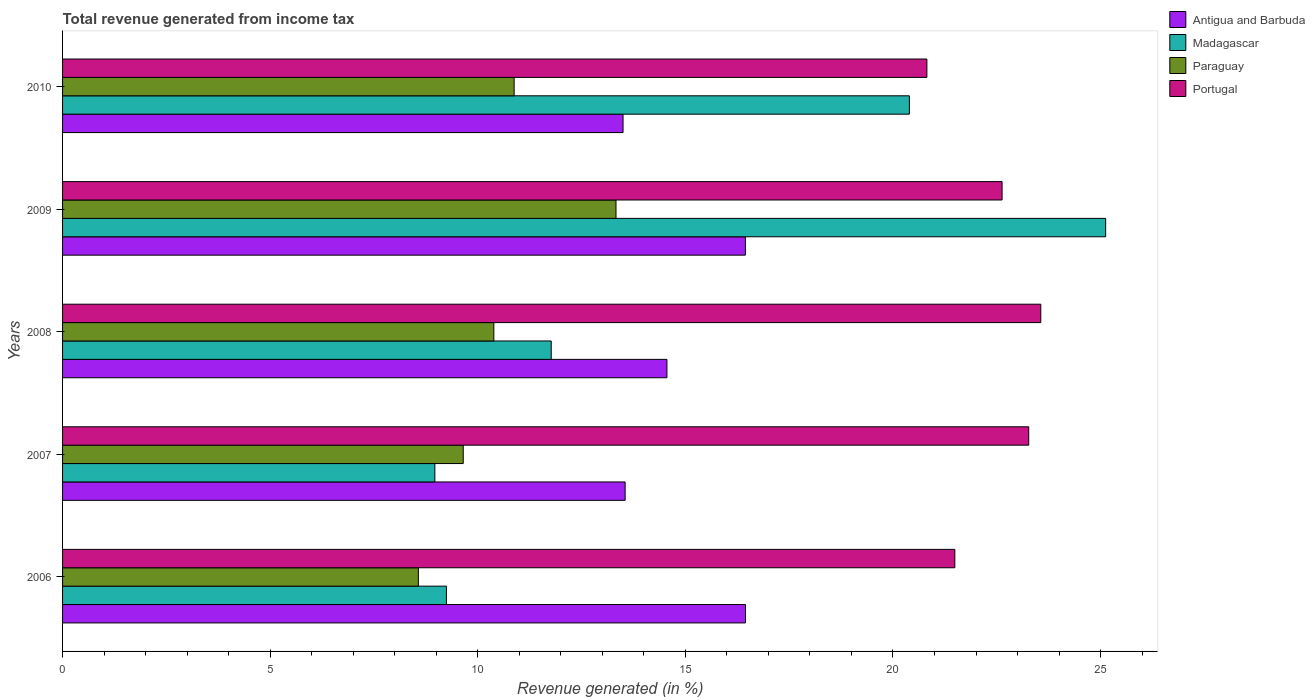How many different coloured bars are there?
Offer a very short reply. 4. How many groups of bars are there?
Offer a terse response. 5. Are the number of bars per tick equal to the number of legend labels?
Keep it short and to the point. Yes. Are the number of bars on each tick of the Y-axis equal?
Make the answer very short. Yes. What is the label of the 5th group of bars from the top?
Offer a very short reply. 2006. In how many cases, is the number of bars for a given year not equal to the number of legend labels?
Provide a short and direct response. 0. What is the total revenue generated in Madagascar in 2006?
Offer a terse response. 9.24. Across all years, what is the maximum total revenue generated in Portugal?
Give a very brief answer. 23.56. Across all years, what is the minimum total revenue generated in Portugal?
Provide a short and direct response. 20.82. In which year was the total revenue generated in Portugal maximum?
Provide a succinct answer. 2008. What is the total total revenue generated in Paraguay in the graph?
Make the answer very short. 52.81. What is the difference between the total revenue generated in Antigua and Barbuda in 2009 and that in 2010?
Provide a short and direct response. 2.95. What is the difference between the total revenue generated in Madagascar in 2006 and the total revenue generated in Antigua and Barbuda in 2010?
Your answer should be compact. -4.25. What is the average total revenue generated in Portugal per year?
Offer a terse response. 22.35. In the year 2007, what is the difference between the total revenue generated in Paraguay and total revenue generated in Antigua and Barbuda?
Offer a very short reply. -3.9. What is the ratio of the total revenue generated in Portugal in 2007 to that in 2009?
Provide a succinct answer. 1.03. Is the total revenue generated in Portugal in 2006 less than that in 2007?
Your answer should be very brief. Yes. What is the difference between the highest and the second highest total revenue generated in Paraguay?
Offer a terse response. 2.45. What is the difference between the highest and the lowest total revenue generated in Paraguay?
Offer a terse response. 4.76. In how many years, is the total revenue generated in Portugal greater than the average total revenue generated in Portugal taken over all years?
Make the answer very short. 3. Is it the case that in every year, the sum of the total revenue generated in Madagascar and total revenue generated in Paraguay is greater than the sum of total revenue generated in Antigua and Barbuda and total revenue generated in Portugal?
Ensure brevity in your answer.  No. What does the 2nd bar from the top in 2007 represents?
Your answer should be very brief. Paraguay. What does the 3rd bar from the bottom in 2009 represents?
Provide a short and direct response. Paraguay. Is it the case that in every year, the sum of the total revenue generated in Portugal and total revenue generated in Antigua and Barbuda is greater than the total revenue generated in Madagascar?
Ensure brevity in your answer.  Yes. Are all the bars in the graph horizontal?
Offer a terse response. Yes. How many years are there in the graph?
Ensure brevity in your answer.  5. Are the values on the major ticks of X-axis written in scientific E-notation?
Provide a succinct answer. No. Does the graph contain any zero values?
Offer a very short reply. No. Where does the legend appear in the graph?
Your answer should be compact. Top right. What is the title of the graph?
Your answer should be compact. Total revenue generated from income tax. Does "Gambia, The" appear as one of the legend labels in the graph?
Keep it short and to the point. No. What is the label or title of the X-axis?
Your answer should be very brief. Revenue generated (in %). What is the label or title of the Y-axis?
Provide a short and direct response. Years. What is the Revenue generated (in %) in Antigua and Barbuda in 2006?
Offer a very short reply. 16.45. What is the Revenue generated (in %) of Madagascar in 2006?
Offer a terse response. 9.24. What is the Revenue generated (in %) in Paraguay in 2006?
Provide a short and direct response. 8.57. What is the Revenue generated (in %) of Portugal in 2006?
Your answer should be compact. 21.49. What is the Revenue generated (in %) in Antigua and Barbuda in 2007?
Provide a succinct answer. 13.55. What is the Revenue generated (in %) in Madagascar in 2007?
Keep it short and to the point. 8.97. What is the Revenue generated (in %) in Paraguay in 2007?
Provide a short and direct response. 9.65. What is the Revenue generated (in %) in Portugal in 2007?
Offer a terse response. 23.27. What is the Revenue generated (in %) in Antigua and Barbuda in 2008?
Offer a very short reply. 14.56. What is the Revenue generated (in %) of Madagascar in 2008?
Offer a very short reply. 11.77. What is the Revenue generated (in %) in Paraguay in 2008?
Give a very brief answer. 10.39. What is the Revenue generated (in %) of Portugal in 2008?
Ensure brevity in your answer.  23.56. What is the Revenue generated (in %) in Antigua and Barbuda in 2009?
Provide a succinct answer. 16.45. What is the Revenue generated (in %) of Madagascar in 2009?
Ensure brevity in your answer.  25.12. What is the Revenue generated (in %) in Paraguay in 2009?
Offer a terse response. 13.33. What is the Revenue generated (in %) of Portugal in 2009?
Offer a very short reply. 22.63. What is the Revenue generated (in %) of Antigua and Barbuda in 2010?
Offer a terse response. 13.5. What is the Revenue generated (in %) of Madagascar in 2010?
Your answer should be very brief. 20.39. What is the Revenue generated (in %) in Paraguay in 2010?
Give a very brief answer. 10.88. What is the Revenue generated (in %) of Portugal in 2010?
Give a very brief answer. 20.82. Across all years, what is the maximum Revenue generated (in %) of Antigua and Barbuda?
Your answer should be compact. 16.45. Across all years, what is the maximum Revenue generated (in %) of Madagascar?
Make the answer very short. 25.12. Across all years, what is the maximum Revenue generated (in %) of Paraguay?
Offer a terse response. 13.33. Across all years, what is the maximum Revenue generated (in %) in Portugal?
Your answer should be compact. 23.56. Across all years, what is the minimum Revenue generated (in %) in Antigua and Barbuda?
Make the answer very short. 13.5. Across all years, what is the minimum Revenue generated (in %) of Madagascar?
Your answer should be compact. 8.97. Across all years, what is the minimum Revenue generated (in %) of Paraguay?
Make the answer very short. 8.57. Across all years, what is the minimum Revenue generated (in %) in Portugal?
Your answer should be very brief. 20.82. What is the total Revenue generated (in %) in Antigua and Barbuda in the graph?
Provide a short and direct response. 74.5. What is the total Revenue generated (in %) in Madagascar in the graph?
Provide a short and direct response. 75.5. What is the total Revenue generated (in %) of Paraguay in the graph?
Your response must be concise. 52.81. What is the total Revenue generated (in %) in Portugal in the graph?
Ensure brevity in your answer.  111.76. What is the difference between the Revenue generated (in %) of Antigua and Barbuda in 2006 and that in 2007?
Offer a terse response. 2.9. What is the difference between the Revenue generated (in %) in Madagascar in 2006 and that in 2007?
Keep it short and to the point. 0.28. What is the difference between the Revenue generated (in %) of Paraguay in 2006 and that in 2007?
Your answer should be very brief. -1.08. What is the difference between the Revenue generated (in %) of Portugal in 2006 and that in 2007?
Offer a very short reply. -1.78. What is the difference between the Revenue generated (in %) of Antigua and Barbuda in 2006 and that in 2008?
Your response must be concise. 1.89. What is the difference between the Revenue generated (in %) of Madagascar in 2006 and that in 2008?
Your response must be concise. -2.52. What is the difference between the Revenue generated (in %) of Paraguay in 2006 and that in 2008?
Ensure brevity in your answer.  -1.82. What is the difference between the Revenue generated (in %) of Portugal in 2006 and that in 2008?
Ensure brevity in your answer.  -2.07. What is the difference between the Revenue generated (in %) of Antigua and Barbuda in 2006 and that in 2009?
Make the answer very short. 0. What is the difference between the Revenue generated (in %) of Madagascar in 2006 and that in 2009?
Give a very brief answer. -15.88. What is the difference between the Revenue generated (in %) of Paraguay in 2006 and that in 2009?
Give a very brief answer. -4.76. What is the difference between the Revenue generated (in %) of Portugal in 2006 and that in 2009?
Your answer should be compact. -1.14. What is the difference between the Revenue generated (in %) in Antigua and Barbuda in 2006 and that in 2010?
Keep it short and to the point. 2.95. What is the difference between the Revenue generated (in %) in Madagascar in 2006 and that in 2010?
Keep it short and to the point. -11.15. What is the difference between the Revenue generated (in %) of Paraguay in 2006 and that in 2010?
Offer a terse response. -2.31. What is the difference between the Revenue generated (in %) in Portugal in 2006 and that in 2010?
Make the answer very short. 0.67. What is the difference between the Revenue generated (in %) of Antigua and Barbuda in 2007 and that in 2008?
Offer a terse response. -1.01. What is the difference between the Revenue generated (in %) of Madagascar in 2007 and that in 2008?
Your answer should be very brief. -2.8. What is the difference between the Revenue generated (in %) in Paraguay in 2007 and that in 2008?
Your response must be concise. -0.74. What is the difference between the Revenue generated (in %) in Portugal in 2007 and that in 2008?
Your answer should be very brief. -0.29. What is the difference between the Revenue generated (in %) in Antigua and Barbuda in 2007 and that in 2009?
Offer a very short reply. -2.9. What is the difference between the Revenue generated (in %) in Madagascar in 2007 and that in 2009?
Provide a succinct answer. -16.16. What is the difference between the Revenue generated (in %) in Paraguay in 2007 and that in 2009?
Offer a terse response. -3.68. What is the difference between the Revenue generated (in %) of Portugal in 2007 and that in 2009?
Give a very brief answer. 0.64. What is the difference between the Revenue generated (in %) of Antigua and Barbuda in 2007 and that in 2010?
Give a very brief answer. 0.05. What is the difference between the Revenue generated (in %) of Madagascar in 2007 and that in 2010?
Ensure brevity in your answer.  -11.43. What is the difference between the Revenue generated (in %) in Paraguay in 2007 and that in 2010?
Keep it short and to the point. -1.23. What is the difference between the Revenue generated (in %) in Portugal in 2007 and that in 2010?
Provide a short and direct response. 2.45. What is the difference between the Revenue generated (in %) of Antigua and Barbuda in 2008 and that in 2009?
Give a very brief answer. -1.89. What is the difference between the Revenue generated (in %) in Madagascar in 2008 and that in 2009?
Provide a succinct answer. -13.35. What is the difference between the Revenue generated (in %) of Paraguay in 2008 and that in 2009?
Your answer should be compact. -2.94. What is the difference between the Revenue generated (in %) of Portugal in 2008 and that in 2009?
Your response must be concise. 0.93. What is the difference between the Revenue generated (in %) in Antigua and Barbuda in 2008 and that in 2010?
Provide a succinct answer. 1.06. What is the difference between the Revenue generated (in %) in Madagascar in 2008 and that in 2010?
Your response must be concise. -8.63. What is the difference between the Revenue generated (in %) in Paraguay in 2008 and that in 2010?
Provide a succinct answer. -0.49. What is the difference between the Revenue generated (in %) in Portugal in 2008 and that in 2010?
Make the answer very short. 2.74. What is the difference between the Revenue generated (in %) of Antigua and Barbuda in 2009 and that in 2010?
Provide a short and direct response. 2.95. What is the difference between the Revenue generated (in %) of Madagascar in 2009 and that in 2010?
Offer a very short reply. 4.73. What is the difference between the Revenue generated (in %) of Paraguay in 2009 and that in 2010?
Offer a very short reply. 2.45. What is the difference between the Revenue generated (in %) of Portugal in 2009 and that in 2010?
Keep it short and to the point. 1.81. What is the difference between the Revenue generated (in %) of Antigua and Barbuda in 2006 and the Revenue generated (in %) of Madagascar in 2007?
Your response must be concise. 7.48. What is the difference between the Revenue generated (in %) of Antigua and Barbuda in 2006 and the Revenue generated (in %) of Paraguay in 2007?
Your answer should be compact. 6.8. What is the difference between the Revenue generated (in %) in Antigua and Barbuda in 2006 and the Revenue generated (in %) in Portugal in 2007?
Offer a terse response. -6.82. What is the difference between the Revenue generated (in %) of Madagascar in 2006 and the Revenue generated (in %) of Paraguay in 2007?
Offer a terse response. -0.41. What is the difference between the Revenue generated (in %) in Madagascar in 2006 and the Revenue generated (in %) in Portugal in 2007?
Make the answer very short. -14.02. What is the difference between the Revenue generated (in %) in Paraguay in 2006 and the Revenue generated (in %) in Portugal in 2007?
Ensure brevity in your answer.  -14.7. What is the difference between the Revenue generated (in %) of Antigua and Barbuda in 2006 and the Revenue generated (in %) of Madagascar in 2008?
Offer a terse response. 4.68. What is the difference between the Revenue generated (in %) of Antigua and Barbuda in 2006 and the Revenue generated (in %) of Paraguay in 2008?
Your answer should be compact. 6.06. What is the difference between the Revenue generated (in %) of Antigua and Barbuda in 2006 and the Revenue generated (in %) of Portugal in 2008?
Offer a terse response. -7.11. What is the difference between the Revenue generated (in %) in Madagascar in 2006 and the Revenue generated (in %) in Paraguay in 2008?
Provide a succinct answer. -1.14. What is the difference between the Revenue generated (in %) of Madagascar in 2006 and the Revenue generated (in %) of Portugal in 2008?
Offer a terse response. -14.32. What is the difference between the Revenue generated (in %) of Paraguay in 2006 and the Revenue generated (in %) of Portugal in 2008?
Provide a short and direct response. -14.99. What is the difference between the Revenue generated (in %) in Antigua and Barbuda in 2006 and the Revenue generated (in %) in Madagascar in 2009?
Offer a very short reply. -8.67. What is the difference between the Revenue generated (in %) of Antigua and Barbuda in 2006 and the Revenue generated (in %) of Paraguay in 2009?
Your answer should be compact. 3.12. What is the difference between the Revenue generated (in %) of Antigua and Barbuda in 2006 and the Revenue generated (in %) of Portugal in 2009?
Give a very brief answer. -6.18. What is the difference between the Revenue generated (in %) in Madagascar in 2006 and the Revenue generated (in %) in Paraguay in 2009?
Offer a very short reply. -4.08. What is the difference between the Revenue generated (in %) of Madagascar in 2006 and the Revenue generated (in %) of Portugal in 2009?
Ensure brevity in your answer.  -13.38. What is the difference between the Revenue generated (in %) of Paraguay in 2006 and the Revenue generated (in %) of Portugal in 2009?
Provide a short and direct response. -14.06. What is the difference between the Revenue generated (in %) of Antigua and Barbuda in 2006 and the Revenue generated (in %) of Madagascar in 2010?
Your answer should be compact. -3.95. What is the difference between the Revenue generated (in %) of Antigua and Barbuda in 2006 and the Revenue generated (in %) of Paraguay in 2010?
Offer a very short reply. 5.57. What is the difference between the Revenue generated (in %) of Antigua and Barbuda in 2006 and the Revenue generated (in %) of Portugal in 2010?
Offer a very short reply. -4.37. What is the difference between the Revenue generated (in %) in Madagascar in 2006 and the Revenue generated (in %) in Paraguay in 2010?
Provide a short and direct response. -1.63. What is the difference between the Revenue generated (in %) in Madagascar in 2006 and the Revenue generated (in %) in Portugal in 2010?
Offer a very short reply. -11.57. What is the difference between the Revenue generated (in %) of Paraguay in 2006 and the Revenue generated (in %) of Portugal in 2010?
Provide a short and direct response. -12.25. What is the difference between the Revenue generated (in %) in Antigua and Barbuda in 2007 and the Revenue generated (in %) in Madagascar in 2008?
Your response must be concise. 1.78. What is the difference between the Revenue generated (in %) of Antigua and Barbuda in 2007 and the Revenue generated (in %) of Paraguay in 2008?
Ensure brevity in your answer.  3.16. What is the difference between the Revenue generated (in %) in Antigua and Barbuda in 2007 and the Revenue generated (in %) in Portugal in 2008?
Offer a terse response. -10.01. What is the difference between the Revenue generated (in %) of Madagascar in 2007 and the Revenue generated (in %) of Paraguay in 2008?
Give a very brief answer. -1.42. What is the difference between the Revenue generated (in %) of Madagascar in 2007 and the Revenue generated (in %) of Portugal in 2008?
Offer a terse response. -14.59. What is the difference between the Revenue generated (in %) of Paraguay in 2007 and the Revenue generated (in %) of Portugal in 2008?
Give a very brief answer. -13.91. What is the difference between the Revenue generated (in %) in Antigua and Barbuda in 2007 and the Revenue generated (in %) in Madagascar in 2009?
Provide a short and direct response. -11.57. What is the difference between the Revenue generated (in %) of Antigua and Barbuda in 2007 and the Revenue generated (in %) of Paraguay in 2009?
Provide a short and direct response. 0.22. What is the difference between the Revenue generated (in %) of Antigua and Barbuda in 2007 and the Revenue generated (in %) of Portugal in 2009?
Your answer should be very brief. -9.08. What is the difference between the Revenue generated (in %) in Madagascar in 2007 and the Revenue generated (in %) in Paraguay in 2009?
Keep it short and to the point. -4.36. What is the difference between the Revenue generated (in %) in Madagascar in 2007 and the Revenue generated (in %) in Portugal in 2009?
Your answer should be very brief. -13.66. What is the difference between the Revenue generated (in %) of Paraguay in 2007 and the Revenue generated (in %) of Portugal in 2009?
Give a very brief answer. -12.98. What is the difference between the Revenue generated (in %) in Antigua and Barbuda in 2007 and the Revenue generated (in %) in Madagascar in 2010?
Your answer should be compact. -6.85. What is the difference between the Revenue generated (in %) in Antigua and Barbuda in 2007 and the Revenue generated (in %) in Paraguay in 2010?
Your response must be concise. 2.67. What is the difference between the Revenue generated (in %) in Antigua and Barbuda in 2007 and the Revenue generated (in %) in Portugal in 2010?
Ensure brevity in your answer.  -7.27. What is the difference between the Revenue generated (in %) of Madagascar in 2007 and the Revenue generated (in %) of Paraguay in 2010?
Provide a succinct answer. -1.91. What is the difference between the Revenue generated (in %) in Madagascar in 2007 and the Revenue generated (in %) in Portugal in 2010?
Your response must be concise. -11.85. What is the difference between the Revenue generated (in %) in Paraguay in 2007 and the Revenue generated (in %) in Portugal in 2010?
Offer a terse response. -11.17. What is the difference between the Revenue generated (in %) in Antigua and Barbuda in 2008 and the Revenue generated (in %) in Madagascar in 2009?
Make the answer very short. -10.57. What is the difference between the Revenue generated (in %) in Antigua and Barbuda in 2008 and the Revenue generated (in %) in Paraguay in 2009?
Keep it short and to the point. 1.23. What is the difference between the Revenue generated (in %) in Antigua and Barbuda in 2008 and the Revenue generated (in %) in Portugal in 2009?
Provide a succinct answer. -8.07. What is the difference between the Revenue generated (in %) in Madagascar in 2008 and the Revenue generated (in %) in Paraguay in 2009?
Offer a terse response. -1.56. What is the difference between the Revenue generated (in %) in Madagascar in 2008 and the Revenue generated (in %) in Portugal in 2009?
Make the answer very short. -10.86. What is the difference between the Revenue generated (in %) in Paraguay in 2008 and the Revenue generated (in %) in Portugal in 2009?
Your response must be concise. -12.24. What is the difference between the Revenue generated (in %) of Antigua and Barbuda in 2008 and the Revenue generated (in %) of Madagascar in 2010?
Make the answer very short. -5.84. What is the difference between the Revenue generated (in %) in Antigua and Barbuda in 2008 and the Revenue generated (in %) in Paraguay in 2010?
Make the answer very short. 3.68. What is the difference between the Revenue generated (in %) of Antigua and Barbuda in 2008 and the Revenue generated (in %) of Portugal in 2010?
Your answer should be very brief. -6.26. What is the difference between the Revenue generated (in %) in Madagascar in 2008 and the Revenue generated (in %) in Paraguay in 2010?
Ensure brevity in your answer.  0.89. What is the difference between the Revenue generated (in %) in Madagascar in 2008 and the Revenue generated (in %) in Portugal in 2010?
Offer a very short reply. -9.05. What is the difference between the Revenue generated (in %) in Paraguay in 2008 and the Revenue generated (in %) in Portugal in 2010?
Provide a succinct answer. -10.43. What is the difference between the Revenue generated (in %) of Antigua and Barbuda in 2009 and the Revenue generated (in %) of Madagascar in 2010?
Keep it short and to the point. -3.95. What is the difference between the Revenue generated (in %) of Antigua and Barbuda in 2009 and the Revenue generated (in %) of Paraguay in 2010?
Make the answer very short. 5.57. What is the difference between the Revenue generated (in %) in Antigua and Barbuda in 2009 and the Revenue generated (in %) in Portugal in 2010?
Keep it short and to the point. -4.37. What is the difference between the Revenue generated (in %) of Madagascar in 2009 and the Revenue generated (in %) of Paraguay in 2010?
Give a very brief answer. 14.25. What is the difference between the Revenue generated (in %) in Madagascar in 2009 and the Revenue generated (in %) in Portugal in 2010?
Give a very brief answer. 4.31. What is the difference between the Revenue generated (in %) of Paraguay in 2009 and the Revenue generated (in %) of Portugal in 2010?
Your answer should be compact. -7.49. What is the average Revenue generated (in %) in Antigua and Barbuda per year?
Your answer should be compact. 14.9. What is the average Revenue generated (in %) of Madagascar per year?
Ensure brevity in your answer.  15.1. What is the average Revenue generated (in %) in Paraguay per year?
Offer a very short reply. 10.56. What is the average Revenue generated (in %) in Portugal per year?
Offer a terse response. 22.35. In the year 2006, what is the difference between the Revenue generated (in %) of Antigua and Barbuda and Revenue generated (in %) of Madagascar?
Offer a terse response. 7.2. In the year 2006, what is the difference between the Revenue generated (in %) of Antigua and Barbuda and Revenue generated (in %) of Paraguay?
Your response must be concise. 7.88. In the year 2006, what is the difference between the Revenue generated (in %) of Antigua and Barbuda and Revenue generated (in %) of Portugal?
Keep it short and to the point. -5.04. In the year 2006, what is the difference between the Revenue generated (in %) of Madagascar and Revenue generated (in %) of Paraguay?
Your answer should be very brief. 0.68. In the year 2006, what is the difference between the Revenue generated (in %) in Madagascar and Revenue generated (in %) in Portugal?
Provide a short and direct response. -12.25. In the year 2006, what is the difference between the Revenue generated (in %) in Paraguay and Revenue generated (in %) in Portugal?
Offer a very short reply. -12.92. In the year 2007, what is the difference between the Revenue generated (in %) in Antigua and Barbuda and Revenue generated (in %) in Madagascar?
Your response must be concise. 4.58. In the year 2007, what is the difference between the Revenue generated (in %) in Antigua and Barbuda and Revenue generated (in %) in Paraguay?
Your answer should be very brief. 3.9. In the year 2007, what is the difference between the Revenue generated (in %) in Antigua and Barbuda and Revenue generated (in %) in Portugal?
Make the answer very short. -9.72. In the year 2007, what is the difference between the Revenue generated (in %) of Madagascar and Revenue generated (in %) of Paraguay?
Ensure brevity in your answer.  -0.68. In the year 2007, what is the difference between the Revenue generated (in %) in Madagascar and Revenue generated (in %) in Portugal?
Your response must be concise. -14.3. In the year 2007, what is the difference between the Revenue generated (in %) in Paraguay and Revenue generated (in %) in Portugal?
Your answer should be compact. -13.62. In the year 2008, what is the difference between the Revenue generated (in %) of Antigua and Barbuda and Revenue generated (in %) of Madagascar?
Your answer should be compact. 2.79. In the year 2008, what is the difference between the Revenue generated (in %) in Antigua and Barbuda and Revenue generated (in %) in Paraguay?
Ensure brevity in your answer.  4.17. In the year 2008, what is the difference between the Revenue generated (in %) of Antigua and Barbuda and Revenue generated (in %) of Portugal?
Offer a terse response. -9. In the year 2008, what is the difference between the Revenue generated (in %) of Madagascar and Revenue generated (in %) of Paraguay?
Make the answer very short. 1.38. In the year 2008, what is the difference between the Revenue generated (in %) in Madagascar and Revenue generated (in %) in Portugal?
Offer a terse response. -11.79. In the year 2008, what is the difference between the Revenue generated (in %) in Paraguay and Revenue generated (in %) in Portugal?
Provide a short and direct response. -13.17. In the year 2009, what is the difference between the Revenue generated (in %) of Antigua and Barbuda and Revenue generated (in %) of Madagascar?
Your answer should be very brief. -8.68. In the year 2009, what is the difference between the Revenue generated (in %) of Antigua and Barbuda and Revenue generated (in %) of Paraguay?
Your response must be concise. 3.12. In the year 2009, what is the difference between the Revenue generated (in %) of Antigua and Barbuda and Revenue generated (in %) of Portugal?
Your answer should be very brief. -6.18. In the year 2009, what is the difference between the Revenue generated (in %) in Madagascar and Revenue generated (in %) in Paraguay?
Keep it short and to the point. 11.79. In the year 2009, what is the difference between the Revenue generated (in %) of Madagascar and Revenue generated (in %) of Portugal?
Offer a very short reply. 2.49. In the year 2009, what is the difference between the Revenue generated (in %) in Paraguay and Revenue generated (in %) in Portugal?
Provide a succinct answer. -9.3. In the year 2010, what is the difference between the Revenue generated (in %) in Antigua and Barbuda and Revenue generated (in %) in Madagascar?
Your answer should be very brief. -6.9. In the year 2010, what is the difference between the Revenue generated (in %) in Antigua and Barbuda and Revenue generated (in %) in Paraguay?
Provide a short and direct response. 2.62. In the year 2010, what is the difference between the Revenue generated (in %) in Antigua and Barbuda and Revenue generated (in %) in Portugal?
Your answer should be very brief. -7.32. In the year 2010, what is the difference between the Revenue generated (in %) in Madagascar and Revenue generated (in %) in Paraguay?
Provide a succinct answer. 9.52. In the year 2010, what is the difference between the Revenue generated (in %) of Madagascar and Revenue generated (in %) of Portugal?
Give a very brief answer. -0.42. In the year 2010, what is the difference between the Revenue generated (in %) in Paraguay and Revenue generated (in %) in Portugal?
Your answer should be compact. -9.94. What is the ratio of the Revenue generated (in %) in Antigua and Barbuda in 2006 to that in 2007?
Provide a short and direct response. 1.21. What is the ratio of the Revenue generated (in %) of Madagascar in 2006 to that in 2007?
Your response must be concise. 1.03. What is the ratio of the Revenue generated (in %) in Paraguay in 2006 to that in 2007?
Give a very brief answer. 0.89. What is the ratio of the Revenue generated (in %) of Portugal in 2006 to that in 2007?
Keep it short and to the point. 0.92. What is the ratio of the Revenue generated (in %) of Antigua and Barbuda in 2006 to that in 2008?
Give a very brief answer. 1.13. What is the ratio of the Revenue generated (in %) in Madagascar in 2006 to that in 2008?
Your answer should be compact. 0.79. What is the ratio of the Revenue generated (in %) of Paraguay in 2006 to that in 2008?
Your answer should be compact. 0.82. What is the ratio of the Revenue generated (in %) of Portugal in 2006 to that in 2008?
Give a very brief answer. 0.91. What is the ratio of the Revenue generated (in %) in Antigua and Barbuda in 2006 to that in 2009?
Your answer should be very brief. 1. What is the ratio of the Revenue generated (in %) of Madagascar in 2006 to that in 2009?
Give a very brief answer. 0.37. What is the ratio of the Revenue generated (in %) of Paraguay in 2006 to that in 2009?
Your answer should be very brief. 0.64. What is the ratio of the Revenue generated (in %) of Portugal in 2006 to that in 2009?
Keep it short and to the point. 0.95. What is the ratio of the Revenue generated (in %) in Antigua and Barbuda in 2006 to that in 2010?
Ensure brevity in your answer.  1.22. What is the ratio of the Revenue generated (in %) of Madagascar in 2006 to that in 2010?
Your response must be concise. 0.45. What is the ratio of the Revenue generated (in %) of Paraguay in 2006 to that in 2010?
Your answer should be very brief. 0.79. What is the ratio of the Revenue generated (in %) of Portugal in 2006 to that in 2010?
Your answer should be very brief. 1.03. What is the ratio of the Revenue generated (in %) in Antigua and Barbuda in 2007 to that in 2008?
Your response must be concise. 0.93. What is the ratio of the Revenue generated (in %) in Madagascar in 2007 to that in 2008?
Provide a succinct answer. 0.76. What is the ratio of the Revenue generated (in %) in Paraguay in 2007 to that in 2008?
Provide a short and direct response. 0.93. What is the ratio of the Revenue generated (in %) in Antigua and Barbuda in 2007 to that in 2009?
Offer a very short reply. 0.82. What is the ratio of the Revenue generated (in %) in Madagascar in 2007 to that in 2009?
Offer a terse response. 0.36. What is the ratio of the Revenue generated (in %) in Paraguay in 2007 to that in 2009?
Your response must be concise. 0.72. What is the ratio of the Revenue generated (in %) of Portugal in 2007 to that in 2009?
Your response must be concise. 1.03. What is the ratio of the Revenue generated (in %) in Madagascar in 2007 to that in 2010?
Provide a succinct answer. 0.44. What is the ratio of the Revenue generated (in %) in Paraguay in 2007 to that in 2010?
Your answer should be compact. 0.89. What is the ratio of the Revenue generated (in %) of Portugal in 2007 to that in 2010?
Provide a succinct answer. 1.12. What is the ratio of the Revenue generated (in %) of Antigua and Barbuda in 2008 to that in 2009?
Your response must be concise. 0.89. What is the ratio of the Revenue generated (in %) in Madagascar in 2008 to that in 2009?
Ensure brevity in your answer.  0.47. What is the ratio of the Revenue generated (in %) of Paraguay in 2008 to that in 2009?
Give a very brief answer. 0.78. What is the ratio of the Revenue generated (in %) of Portugal in 2008 to that in 2009?
Keep it short and to the point. 1.04. What is the ratio of the Revenue generated (in %) in Antigua and Barbuda in 2008 to that in 2010?
Offer a terse response. 1.08. What is the ratio of the Revenue generated (in %) in Madagascar in 2008 to that in 2010?
Provide a succinct answer. 0.58. What is the ratio of the Revenue generated (in %) of Paraguay in 2008 to that in 2010?
Your answer should be very brief. 0.95. What is the ratio of the Revenue generated (in %) of Portugal in 2008 to that in 2010?
Your answer should be compact. 1.13. What is the ratio of the Revenue generated (in %) of Antigua and Barbuda in 2009 to that in 2010?
Your response must be concise. 1.22. What is the ratio of the Revenue generated (in %) in Madagascar in 2009 to that in 2010?
Keep it short and to the point. 1.23. What is the ratio of the Revenue generated (in %) of Paraguay in 2009 to that in 2010?
Offer a very short reply. 1.23. What is the ratio of the Revenue generated (in %) in Portugal in 2009 to that in 2010?
Keep it short and to the point. 1.09. What is the difference between the highest and the second highest Revenue generated (in %) in Antigua and Barbuda?
Your response must be concise. 0. What is the difference between the highest and the second highest Revenue generated (in %) in Madagascar?
Provide a succinct answer. 4.73. What is the difference between the highest and the second highest Revenue generated (in %) in Paraguay?
Your answer should be very brief. 2.45. What is the difference between the highest and the second highest Revenue generated (in %) in Portugal?
Offer a terse response. 0.29. What is the difference between the highest and the lowest Revenue generated (in %) of Antigua and Barbuda?
Your response must be concise. 2.95. What is the difference between the highest and the lowest Revenue generated (in %) in Madagascar?
Keep it short and to the point. 16.16. What is the difference between the highest and the lowest Revenue generated (in %) of Paraguay?
Your response must be concise. 4.76. What is the difference between the highest and the lowest Revenue generated (in %) of Portugal?
Keep it short and to the point. 2.74. 